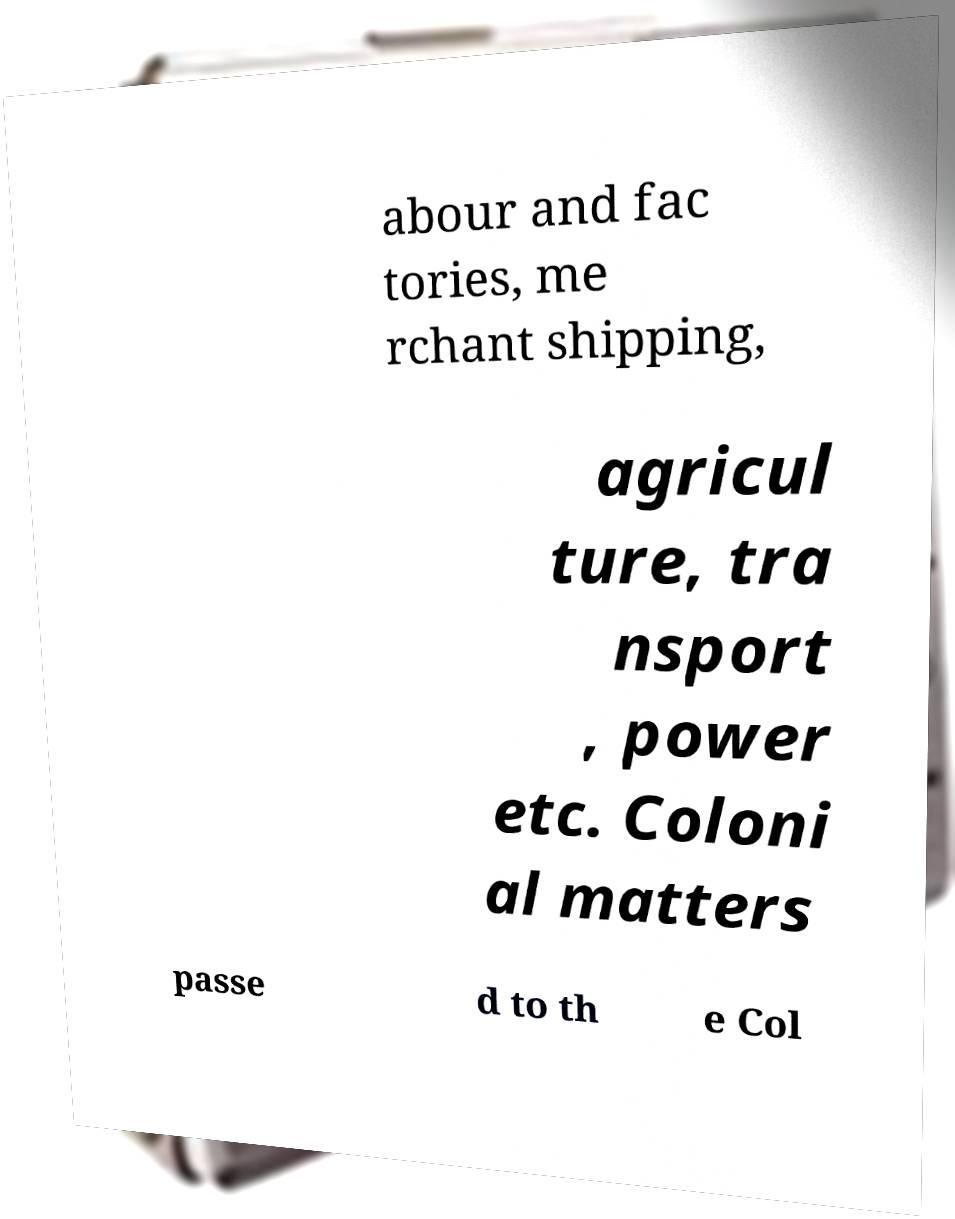Can you read and provide the text displayed in the image?This photo seems to have some interesting text. Can you extract and type it out for me? abour and fac tories, me rchant shipping, agricul ture, tra nsport , power etc. Coloni al matters passe d to th e Col 